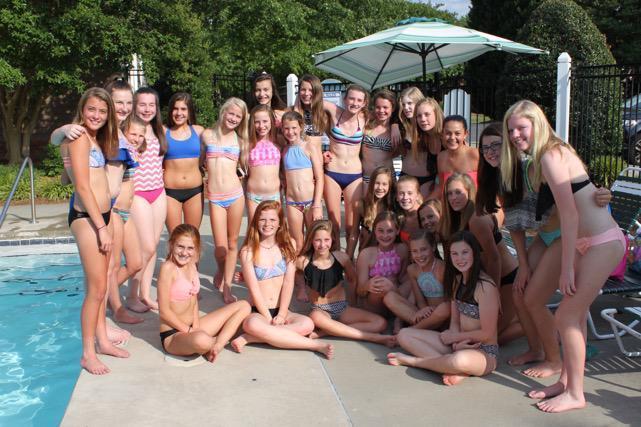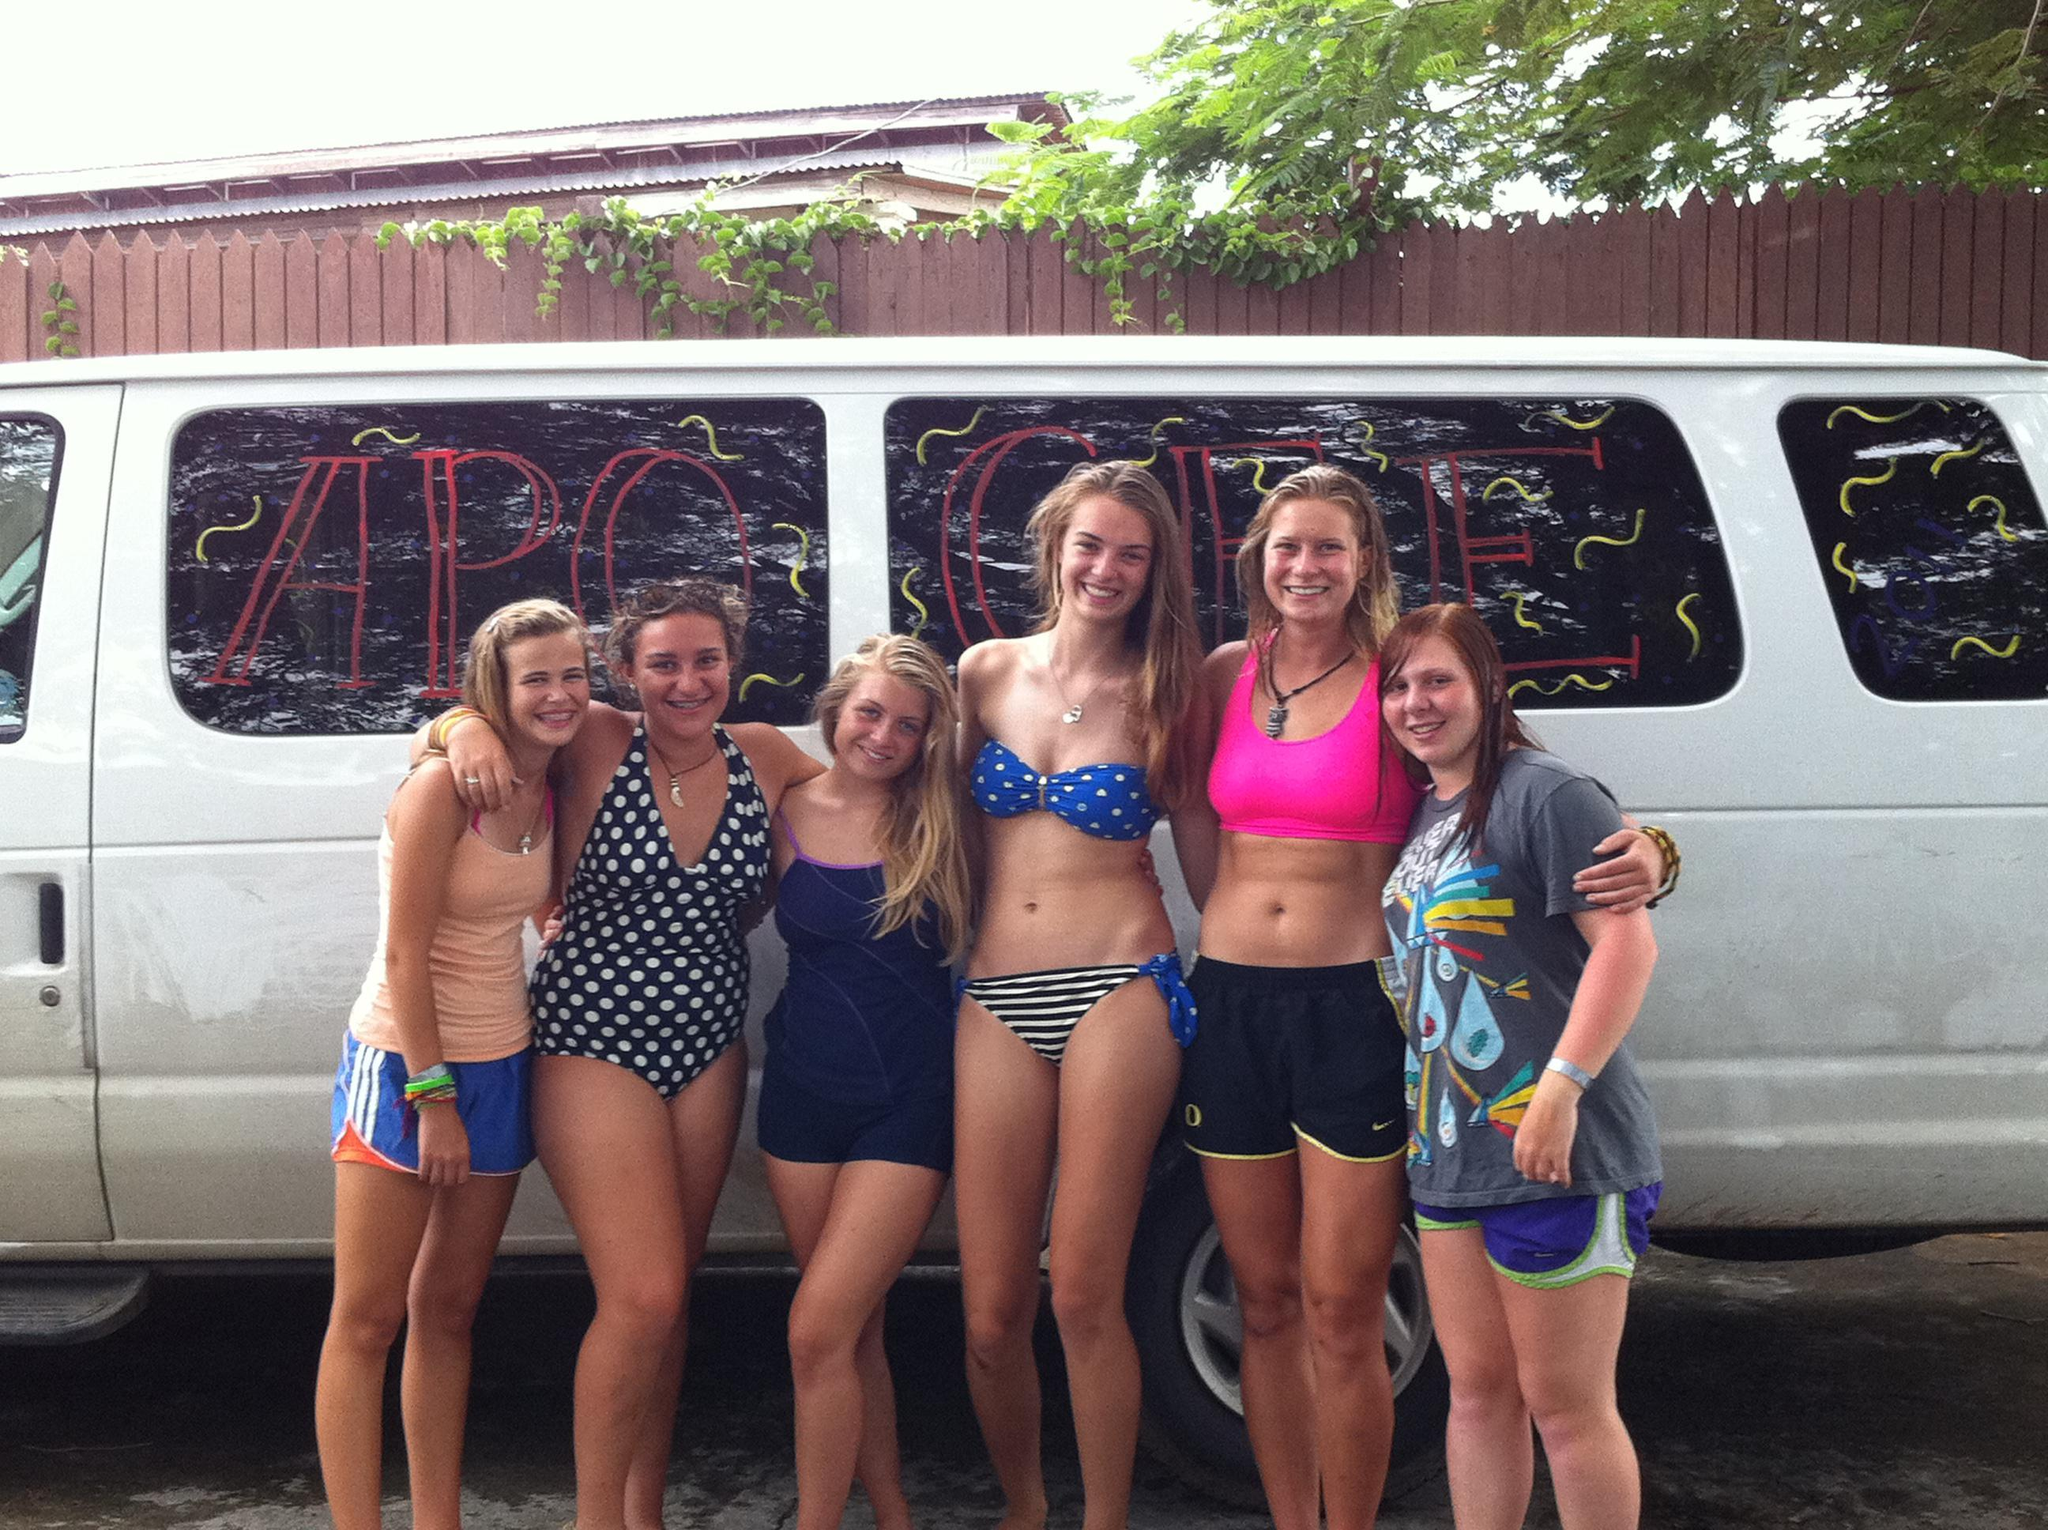The first image is the image on the left, the second image is the image on the right. Considering the images on both sides, is "In at least one image there is a total of five women in bikinis standing in a row." valid? Answer yes or no. No. The first image is the image on the left, the second image is the image on the right. Evaluate the accuracy of this statement regarding the images: "One girl has her body turned forward and the rest have their rears to the camera in one image.". Is it true? Answer yes or no. No. 